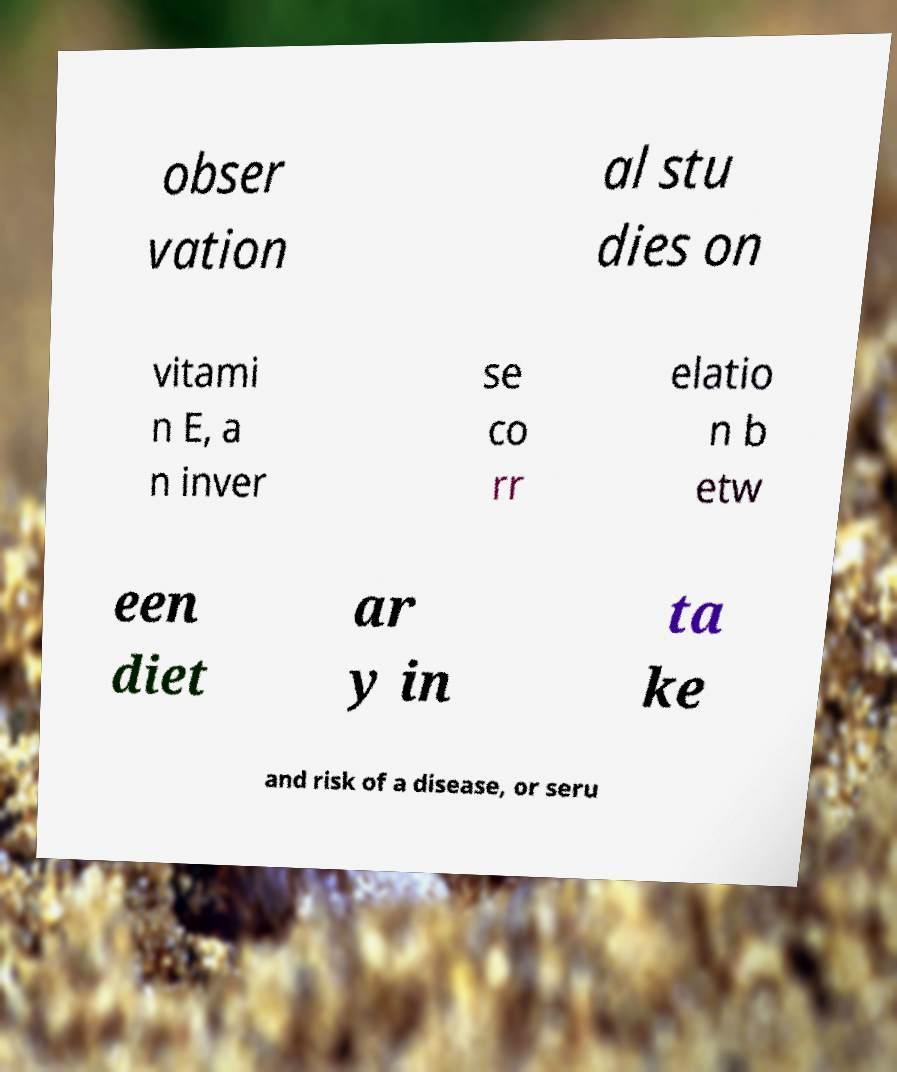Could you extract and type out the text from this image? obser vation al stu dies on vitami n E, a n inver se co rr elatio n b etw een diet ar y in ta ke and risk of a disease, or seru 